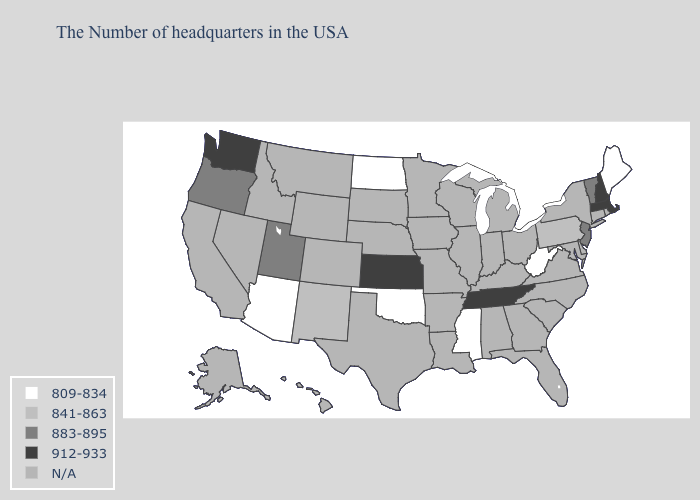What is the value of Iowa?
Keep it brief. N/A. Name the states that have a value in the range 883-895?
Quick response, please. Vermont, New Jersey, Utah, Oregon. What is the value of Oregon?
Quick response, please. 883-895. Which states have the lowest value in the West?
Short answer required. Arizona. Name the states that have a value in the range 841-863?
Answer briefly. Pennsylvania, New Mexico. How many symbols are there in the legend?
Concise answer only. 5. Name the states that have a value in the range 912-933?
Give a very brief answer. Massachusetts, New Hampshire, Tennessee, Kansas, Washington. Does Mississippi have the lowest value in the USA?
Concise answer only. Yes. Name the states that have a value in the range 883-895?
Short answer required. Vermont, New Jersey, Utah, Oregon. Does Kansas have the highest value in the USA?
Write a very short answer. Yes. Name the states that have a value in the range 912-933?
Write a very short answer. Massachusetts, New Hampshire, Tennessee, Kansas, Washington. 